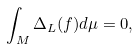<formula> <loc_0><loc_0><loc_500><loc_500>\int _ { M } \Delta _ { L } ( f ) d \mu = 0 ,</formula> 